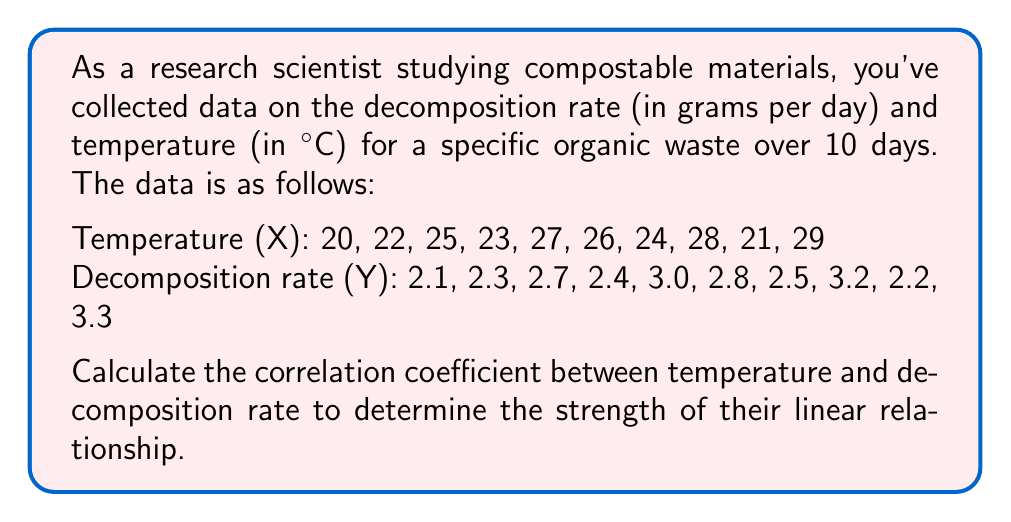Provide a solution to this math problem. To calculate the correlation coefficient (r), we'll use the formula:

$$ r = \frac{\sum_{i=1}^{n} (x_i - \bar{x})(y_i - \bar{y})}{\sqrt{\sum_{i=1}^{n} (x_i - \bar{x})^2 \sum_{i=1}^{n} (y_i - \bar{y})^2}} $$

Step 1: Calculate the means $\bar{x}$ and $\bar{y}$
$\bar{x} = \frac{20 + 22 + 25 + 23 + 27 + 26 + 24 + 28 + 21 + 29}{10} = 24.5$
$\bar{y} = \frac{2.1 + 2.3 + 2.7 + 2.4 + 3.0 + 2.8 + 2.5 + 3.2 + 2.2 + 3.3}{10} = 2.65$

Step 2: Calculate $(x_i - \bar{x})$, $(y_i - \bar{y})$, $(x_i - \bar{x})^2$, $(y_i - \bar{y})^2$, and $(x_i - \bar{x})(y_i - \bar{y})$ for each pair

Step 3: Sum up the values from Step 2
$\sum (x_i - \bar{x})(y_i - \bar{y}) = 15.45$
$\sum (x_i - \bar{x})^2 = 102.5$
$\sum (y_i - \bar{y})^2 = 1.525$

Step 4: Apply the formula
$$ r = \frac{15.45}{\sqrt{102.5 \times 1.525}} = \frac{15.45}{12.5} = 0.9816 $$
Answer: $r \approx 0.9816$ 